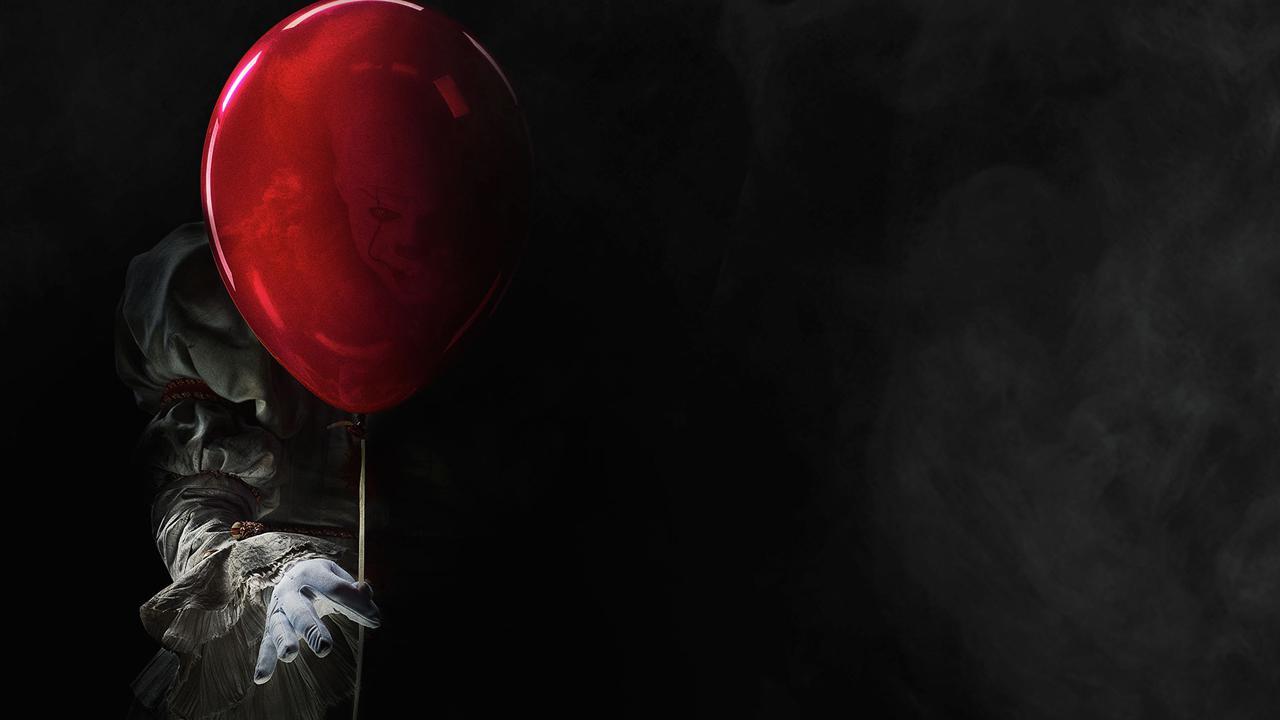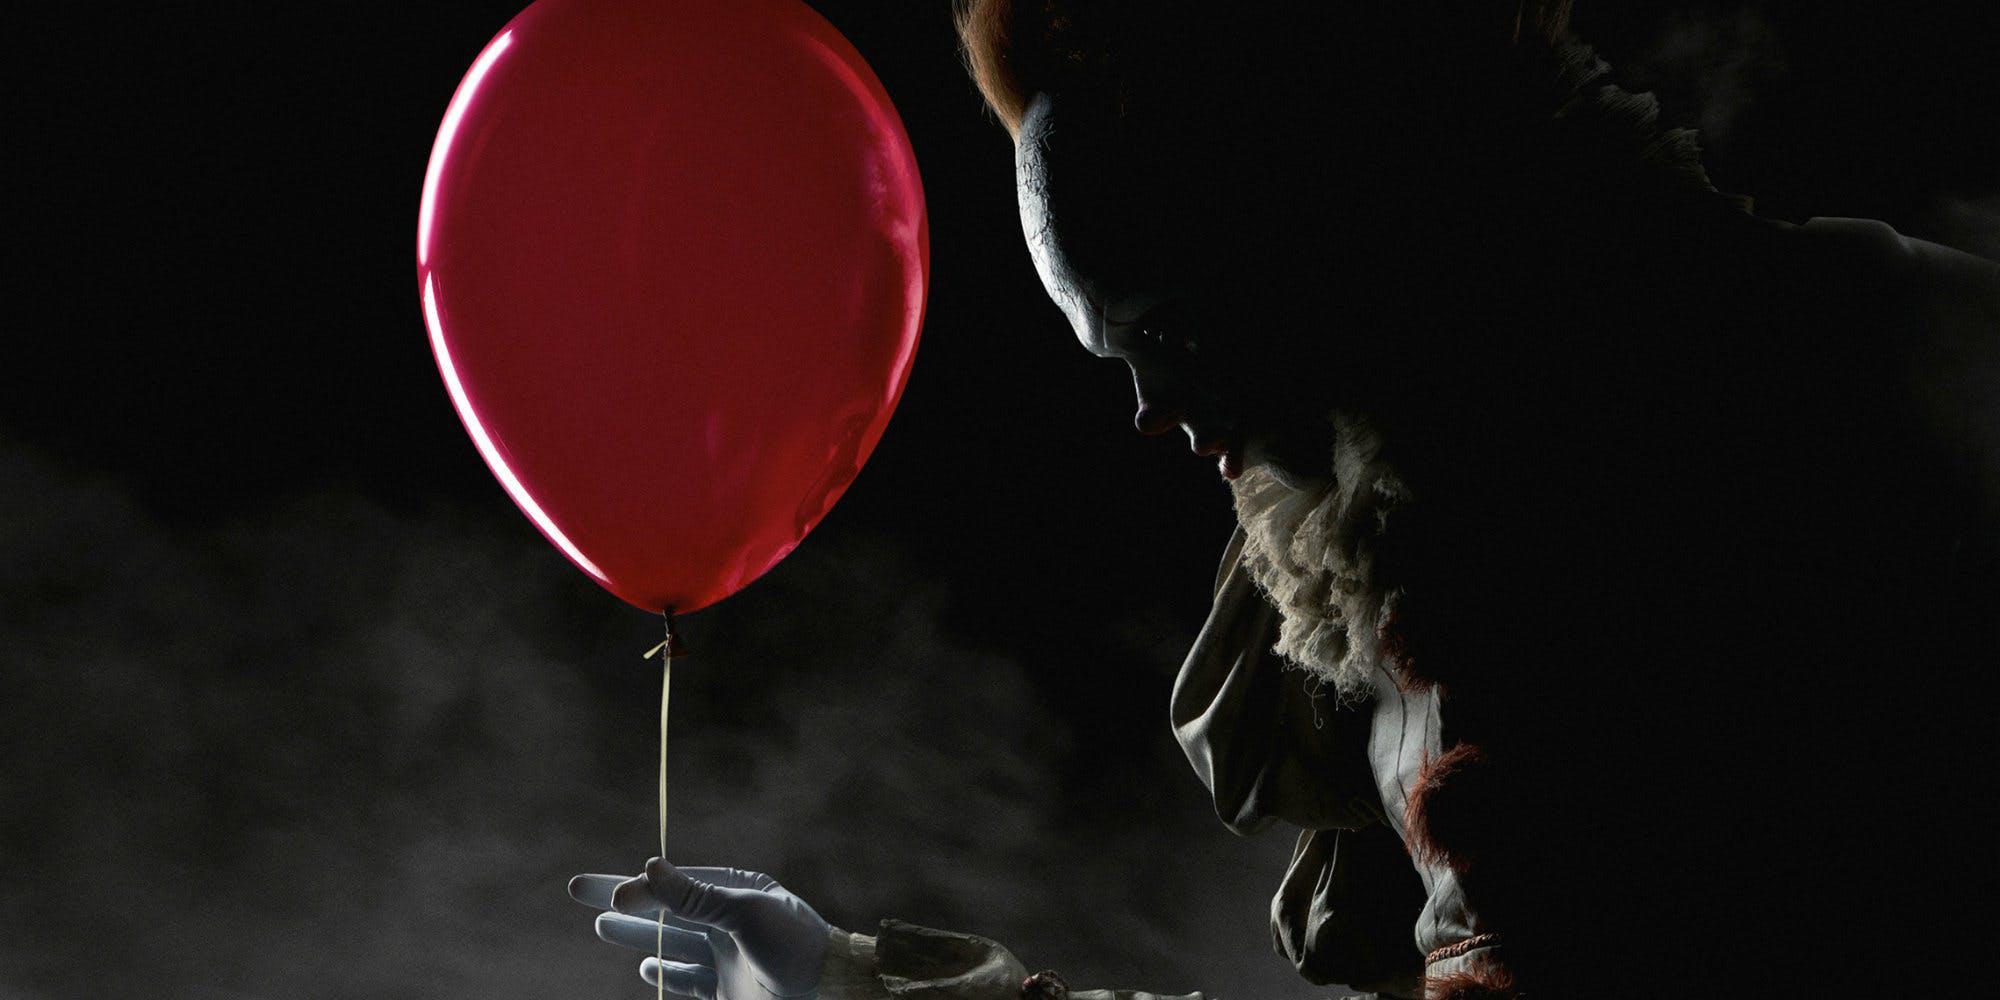The first image is the image on the left, the second image is the image on the right. Examine the images to the left and right. Is the description "There are four eyes." accurate? Answer yes or no. No. 